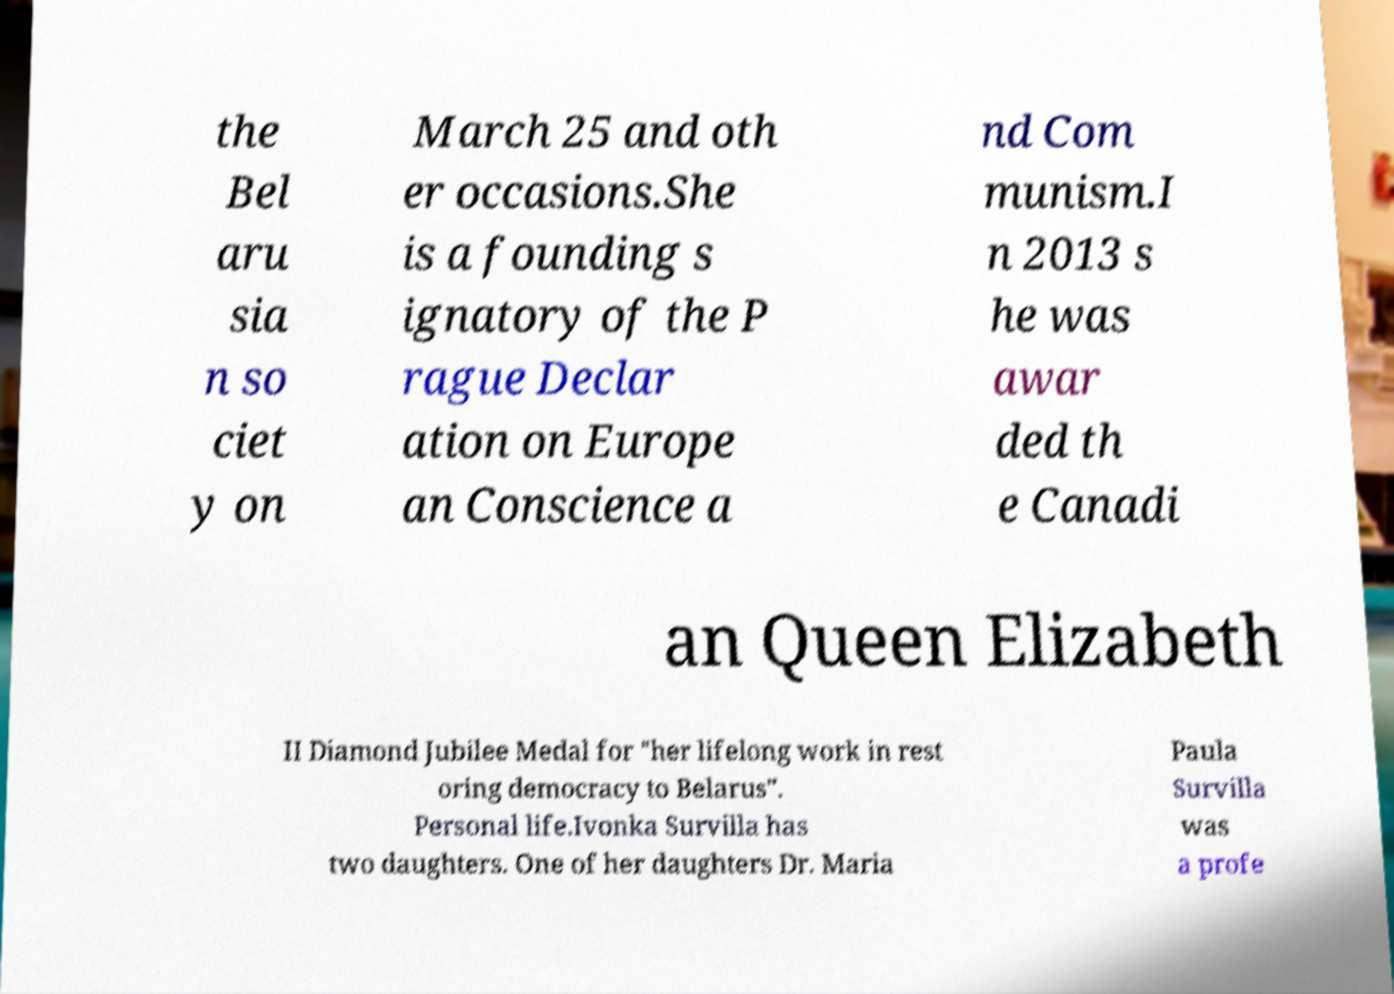Can you accurately transcribe the text from the provided image for me? the Bel aru sia n so ciet y on March 25 and oth er occasions.She is a founding s ignatory of the P rague Declar ation on Europe an Conscience a nd Com munism.I n 2013 s he was awar ded th e Canadi an Queen Elizabeth II Diamond Jubilee Medal for "her lifelong work in rest oring democracy to Belarus". Personal life.Ivonka Survilla has two daughters. One of her daughters Dr. Maria Paula Survilla was a profe 